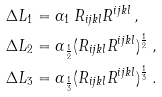Convert formula to latex. <formula><loc_0><loc_0><loc_500><loc_500>\Delta L _ { 1 } & = \alpha _ { 1 } \, R _ { i j k l } R ^ { i j k l } \, , \\ \Delta L _ { 2 } & = \alpha _ { \frac { 1 } { 2 } } ( R _ { i j k l } R ^ { i j k l } ) ^ { \frac { 1 } { 2 } } \, , \\ \Delta L _ { 3 } & = \alpha _ { \frac { 1 } { 3 } } ( R _ { i j k l } R ^ { i j k l } ) ^ { \frac { 1 } { 3 } } \, .</formula> 